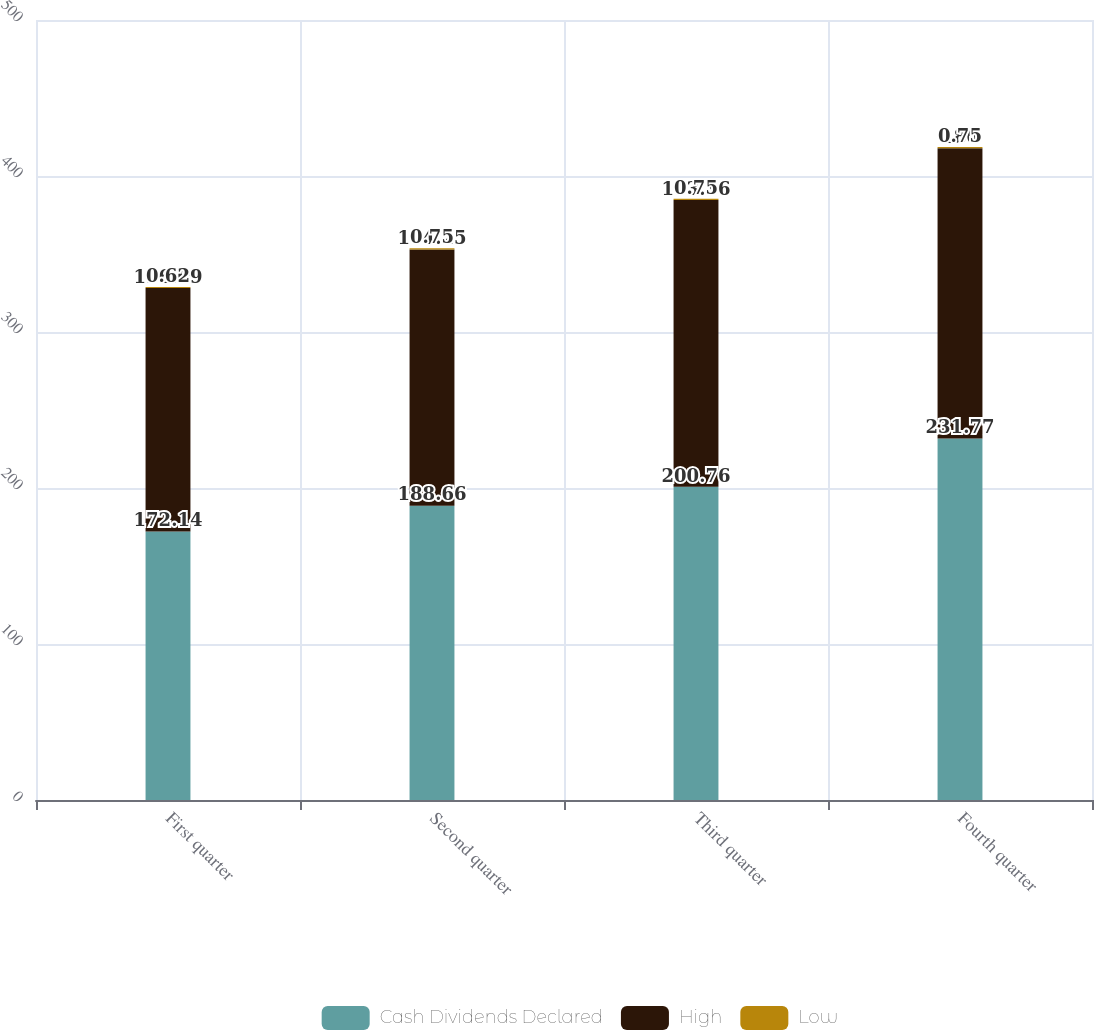Convert chart. <chart><loc_0><loc_0><loc_500><loc_500><stacked_bar_chart><ecel><fcel>First quarter<fcel>Second quarter<fcel>Third quarter<fcel>Fourth quarter<nl><fcel>Cash Dividends Declared<fcel>172.14<fcel>188.66<fcel>200.76<fcel>231.77<nl><fcel>High<fcel>156.09<fcel>164.25<fcel>183.86<fcel>186<nl><fcel>Low<fcel>0.62<fcel>0.75<fcel>0.75<fcel>0.75<nl></chart> 